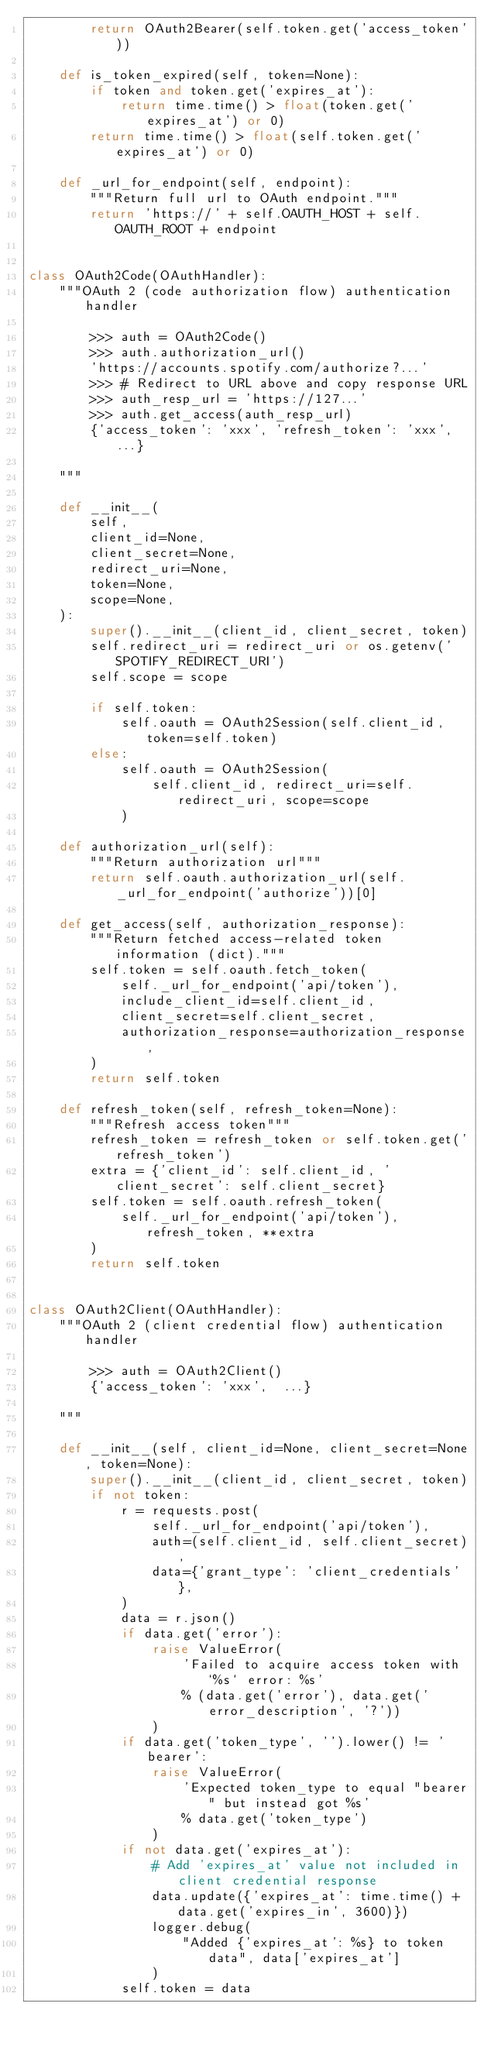<code> <loc_0><loc_0><loc_500><loc_500><_Python_>        return OAuth2Bearer(self.token.get('access_token'))

    def is_token_expired(self, token=None):
        if token and token.get('expires_at'):
            return time.time() > float(token.get('expires_at') or 0)
        return time.time() > float(self.token.get('expires_at') or 0)

    def _url_for_endpoint(self, endpoint):
        """Return full url to OAuth endpoint."""
        return 'https://' + self.OAUTH_HOST + self.OAUTH_ROOT + endpoint


class OAuth2Code(OAuthHandler):
    """OAuth 2 (code authorization flow) authentication handler

        >>> auth = OAuth2Code()
        >>> auth.authorization_url()
        'https://accounts.spotify.com/authorize?...'
        >>> # Redirect to URL above and copy response URL
        >>> auth_resp_url = 'https://127...'
        >>> auth.get_access(auth_resp_url)
        {'access_token': 'xxx', 'refresh_token': 'xxx', ...}

    """

    def __init__(
        self,
        client_id=None,
        client_secret=None,
        redirect_uri=None,
        token=None,
        scope=None,
    ):
        super().__init__(client_id, client_secret, token)
        self.redirect_uri = redirect_uri or os.getenv('SPOTIFY_REDIRECT_URI')
        self.scope = scope

        if self.token:
            self.oauth = OAuth2Session(self.client_id, token=self.token)
        else:
            self.oauth = OAuth2Session(
                self.client_id, redirect_uri=self.redirect_uri, scope=scope
            )

    def authorization_url(self):
        """Return authorization url"""
        return self.oauth.authorization_url(self._url_for_endpoint('authorize'))[0]

    def get_access(self, authorization_response):
        """Return fetched access-related token information (dict)."""
        self.token = self.oauth.fetch_token(
            self._url_for_endpoint('api/token'),
            include_client_id=self.client_id,
            client_secret=self.client_secret,
            authorization_response=authorization_response,
        )
        return self.token

    def refresh_token(self, refresh_token=None):
        """Refresh access token"""
        refresh_token = refresh_token or self.token.get('refresh_token')
        extra = {'client_id': self.client_id, 'client_secret': self.client_secret}
        self.token = self.oauth.refresh_token(
            self._url_for_endpoint('api/token'), refresh_token, **extra
        )
        return self.token


class OAuth2Client(OAuthHandler):
    """OAuth 2 (client credential flow) authentication handler

        >>> auth = OAuth2Client()
        {'access_token': 'xxx',  ...}

    """

    def __init__(self, client_id=None, client_secret=None, token=None):
        super().__init__(client_id, client_secret, token)
        if not token:
            r = requests.post(
                self._url_for_endpoint('api/token'),
                auth=(self.client_id, self.client_secret),
                data={'grant_type': 'client_credentials'},
            )
            data = r.json()
            if data.get('error'):
                raise ValueError(
                    'Failed to acquire access token with `%s` error: %s'
                    % (data.get('error'), data.get('error_description', '?'))
                )
            if data.get('token_type', '').lower() != 'bearer':
                raise ValueError(
                    'Expected token_type to equal "bearer" but instead got %s'
                    % data.get('token_type')
                )
            if not data.get('expires_at'):
                # Add 'expires_at' value not included in client credential response
                data.update({'expires_at': time.time() + data.get('expires_in', 3600)})
                logger.debug(
                    "Added {'expires_at': %s} to token data", data['expires_at']
                )
            self.token = data
</code> 